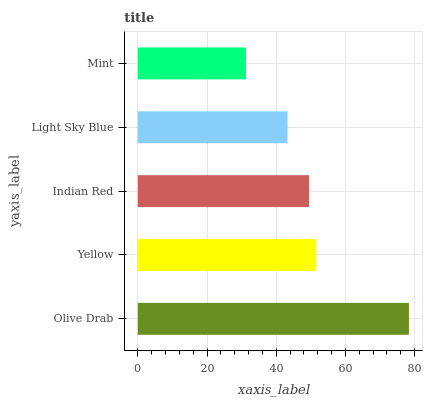Is Mint the minimum?
Answer yes or no. Yes. Is Olive Drab the maximum?
Answer yes or no. Yes. Is Yellow the minimum?
Answer yes or no. No. Is Yellow the maximum?
Answer yes or no. No. Is Olive Drab greater than Yellow?
Answer yes or no. Yes. Is Yellow less than Olive Drab?
Answer yes or no. Yes. Is Yellow greater than Olive Drab?
Answer yes or no. No. Is Olive Drab less than Yellow?
Answer yes or no. No. Is Indian Red the high median?
Answer yes or no. Yes. Is Indian Red the low median?
Answer yes or no. Yes. Is Mint the high median?
Answer yes or no. No. Is Mint the low median?
Answer yes or no. No. 